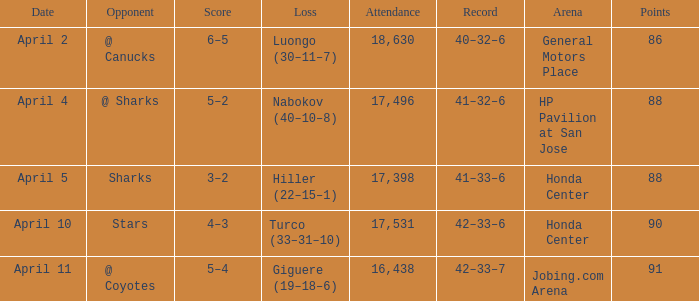Which attendance has over 90 points? 16438.0. 